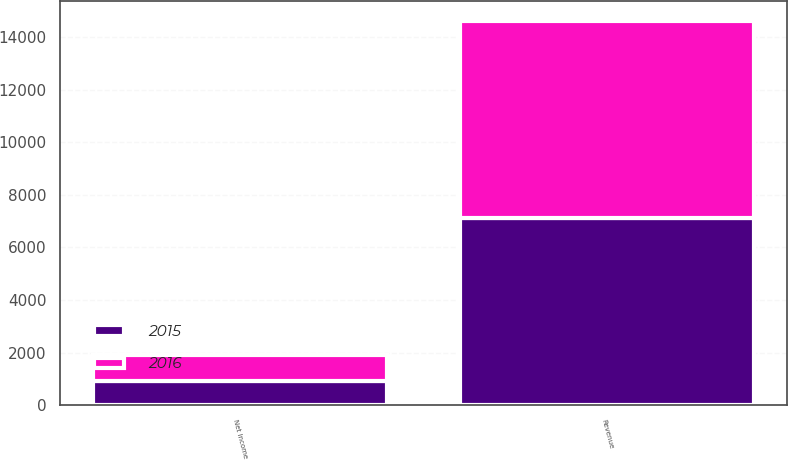<chart> <loc_0><loc_0><loc_500><loc_500><stacked_bar_chart><ecel><fcel>Revenue<fcel>Net Income<nl><fcel>2016<fcel>7511<fcel>1008<nl><fcel>2015<fcel>7111<fcel>914<nl></chart> 